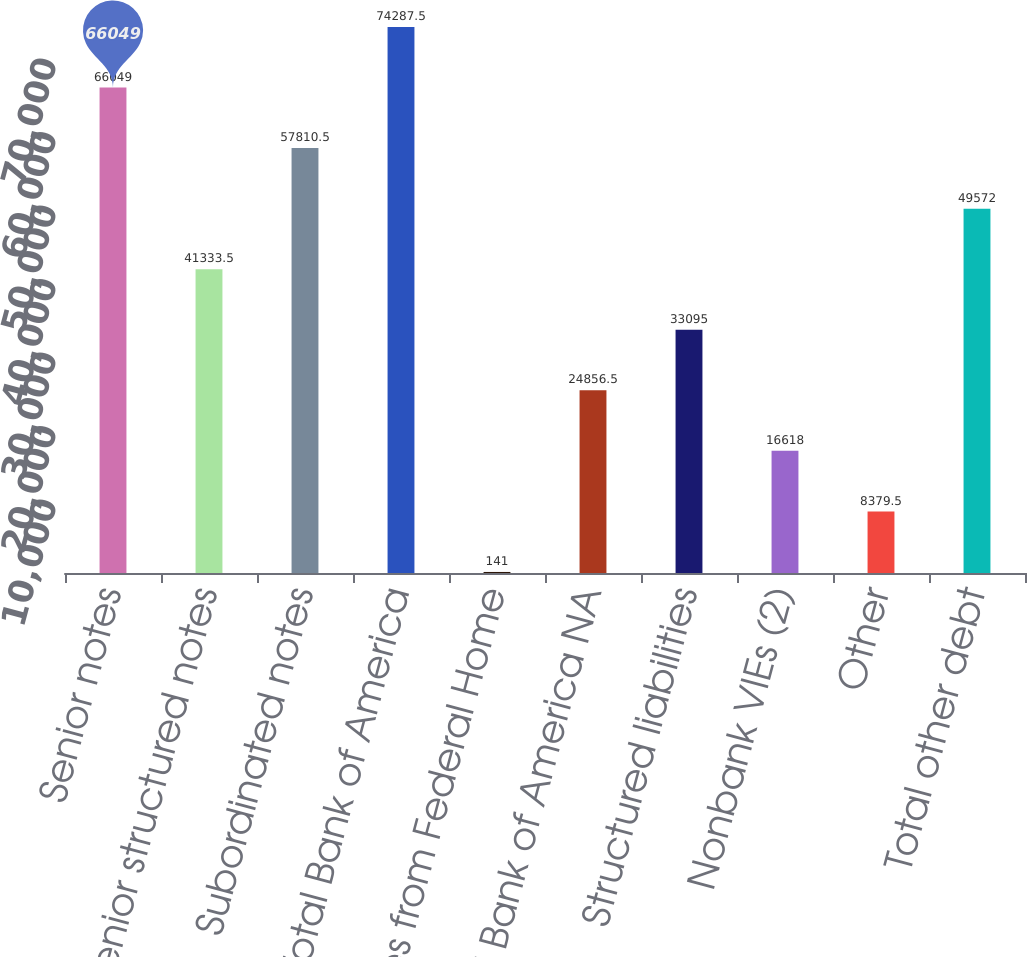<chart> <loc_0><loc_0><loc_500><loc_500><bar_chart><fcel>Senior notes<fcel>Senior structured notes<fcel>Subordinated notes<fcel>Total Bank of America<fcel>Advances from Federal Home<fcel>Total Bank of America NA<fcel>Structured liabilities<fcel>Nonbank VIEs (2)<fcel>Other<fcel>Total other debt<nl><fcel>66049<fcel>41333.5<fcel>57810.5<fcel>74287.5<fcel>141<fcel>24856.5<fcel>33095<fcel>16618<fcel>8379.5<fcel>49572<nl></chart> 